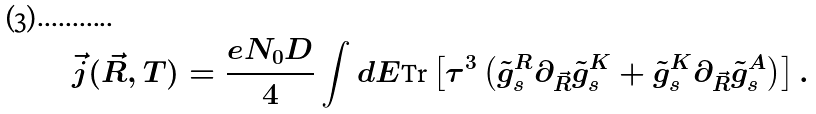Convert formula to latex. <formula><loc_0><loc_0><loc_500><loc_500>\vec { j } ( \vec { R } , T ) = \frac { e N _ { 0 } D } { 4 } \int d E \text {Tr} \left [ \tau ^ { 3 } \left ( \tilde { g } _ { s } ^ { R } \partial _ { \vec { R } } \tilde { g } _ { s } ^ { K } + \tilde { g } _ { s } ^ { K } \partial _ { \vec { R } } \tilde { g } _ { s } ^ { A } \right ) \right ] .</formula> 